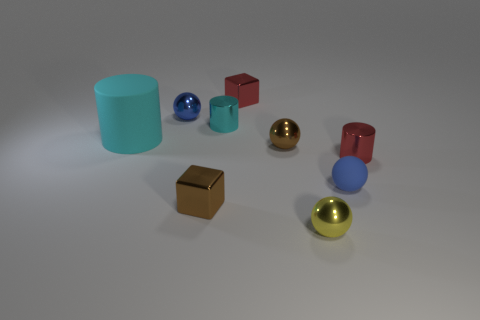There is a brown thing that is on the right side of the tiny brown cube in front of the large cyan thing; what is it made of?
Ensure brevity in your answer.  Metal. There is a small object that is both right of the tiny cyan cylinder and behind the big rubber thing; what is its shape?
Your answer should be very brief. Cube. What number of other things are there of the same color as the large matte object?
Your response must be concise. 1. How many things are either small spheres on the right side of the tiny blue shiny sphere or yellow objects?
Your answer should be compact. 3. Do the matte cylinder and the tiny metal cylinder that is right of the yellow shiny object have the same color?
Give a very brief answer. No. Are there any other things that have the same size as the matte sphere?
Keep it short and to the point. Yes. There is a blue thing that is behind the metallic cylinder in front of the large cyan cylinder; what size is it?
Make the answer very short. Small. What number of things are either tiny blue things or small brown objects in front of the tiny matte sphere?
Your answer should be compact. 3. There is a yellow object in front of the small brown block; is it the same shape as the large cyan rubber object?
Provide a succinct answer. No. There is a small cylinder that is right of the tiny block that is behind the blue rubber thing; how many blue matte spheres are in front of it?
Give a very brief answer. 1. 